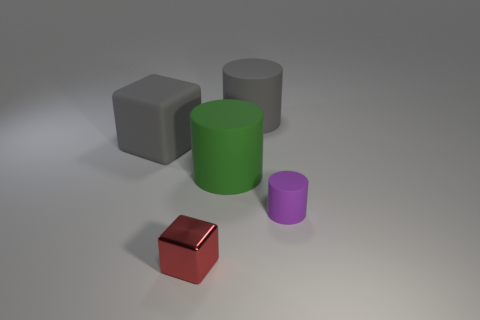Are there any big blocks made of the same material as the big green cylinder?
Your answer should be very brief. Yes. There is a large cylinder behind the large gray rubber cube; does it have the same color as the cube behind the purple cylinder?
Offer a very short reply. Yes. Are there fewer tiny metal objects that are behind the green object than small brown balls?
Make the answer very short. No. How many things are either tiny purple matte things or objects behind the small purple matte cylinder?
Give a very brief answer. 4. What color is the big cube that is made of the same material as the large green object?
Ensure brevity in your answer.  Gray. What number of things are either red things or big cubes?
Provide a short and direct response. 2. What color is the metal block that is the same size as the purple thing?
Offer a terse response. Red. How many objects are large matte things that are to the left of the green object or metal spheres?
Give a very brief answer. 1. How many other things are there of the same size as the gray rubber cylinder?
Keep it short and to the point. 2. What is the size of the cube in front of the purple rubber object?
Offer a terse response. Small. 